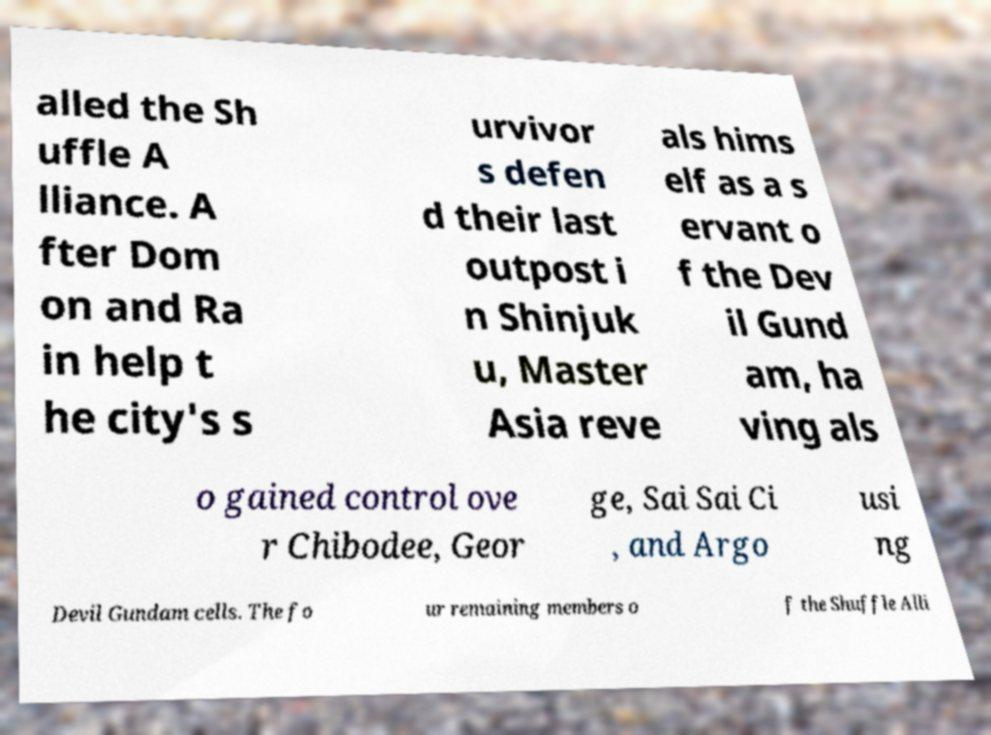Can you accurately transcribe the text from the provided image for me? alled the Sh uffle A lliance. A fter Dom on and Ra in help t he city's s urvivor s defen d their last outpost i n Shinjuk u, Master Asia reve als hims elf as a s ervant o f the Dev il Gund am, ha ving als o gained control ove r Chibodee, Geor ge, Sai Sai Ci , and Argo usi ng Devil Gundam cells. The fo ur remaining members o f the Shuffle Alli 